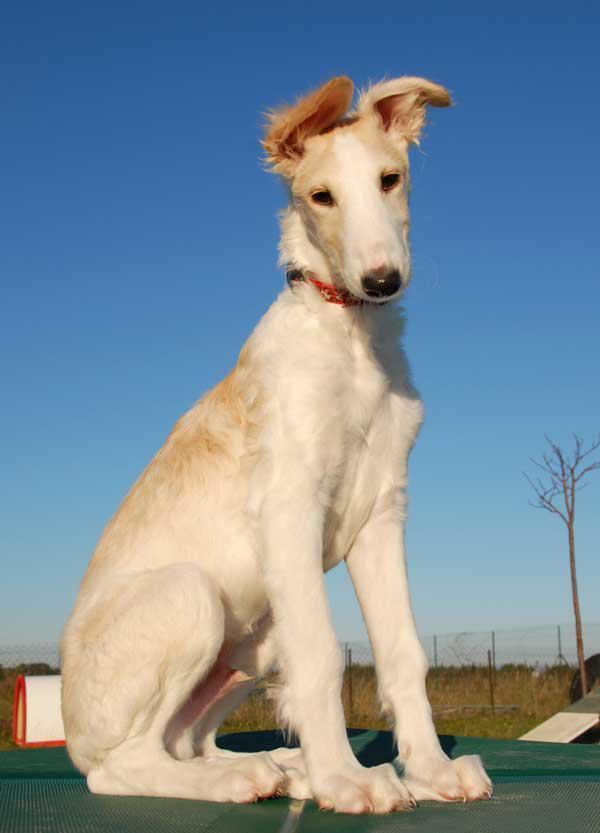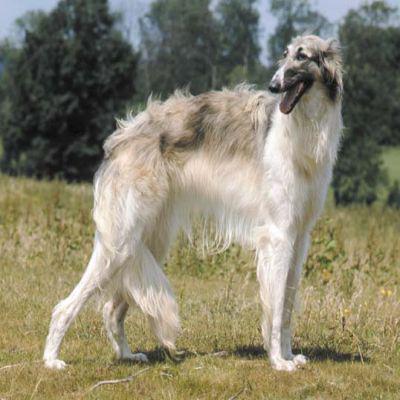The first image is the image on the left, the second image is the image on the right. Evaluate the accuracy of this statement regarding the images: "One dog is sitting on its bottom.". Is it true? Answer yes or no. Yes. The first image is the image on the left, the second image is the image on the right. Analyze the images presented: Is the assertion "One of the dogs is sitting on its haunches." valid? Answer yes or no. Yes. 